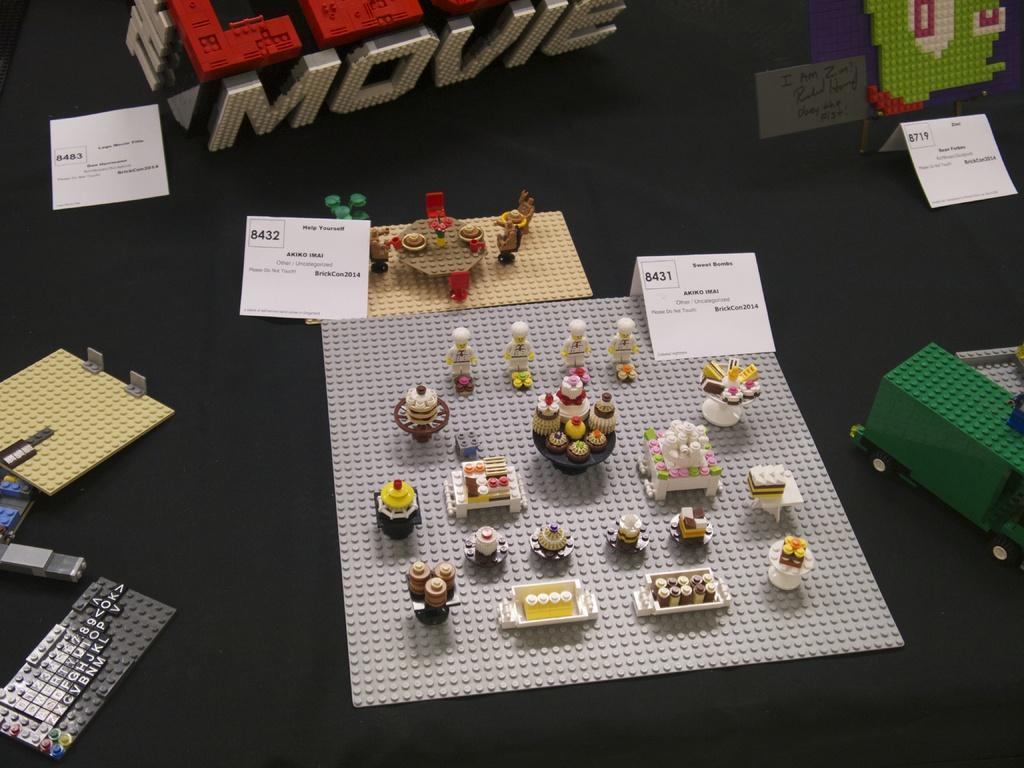How would you summarize this image in a sentence or two? In this image I can see few lego structures and I can see few cupcakes, white color boards and few objects on the black color surface. 